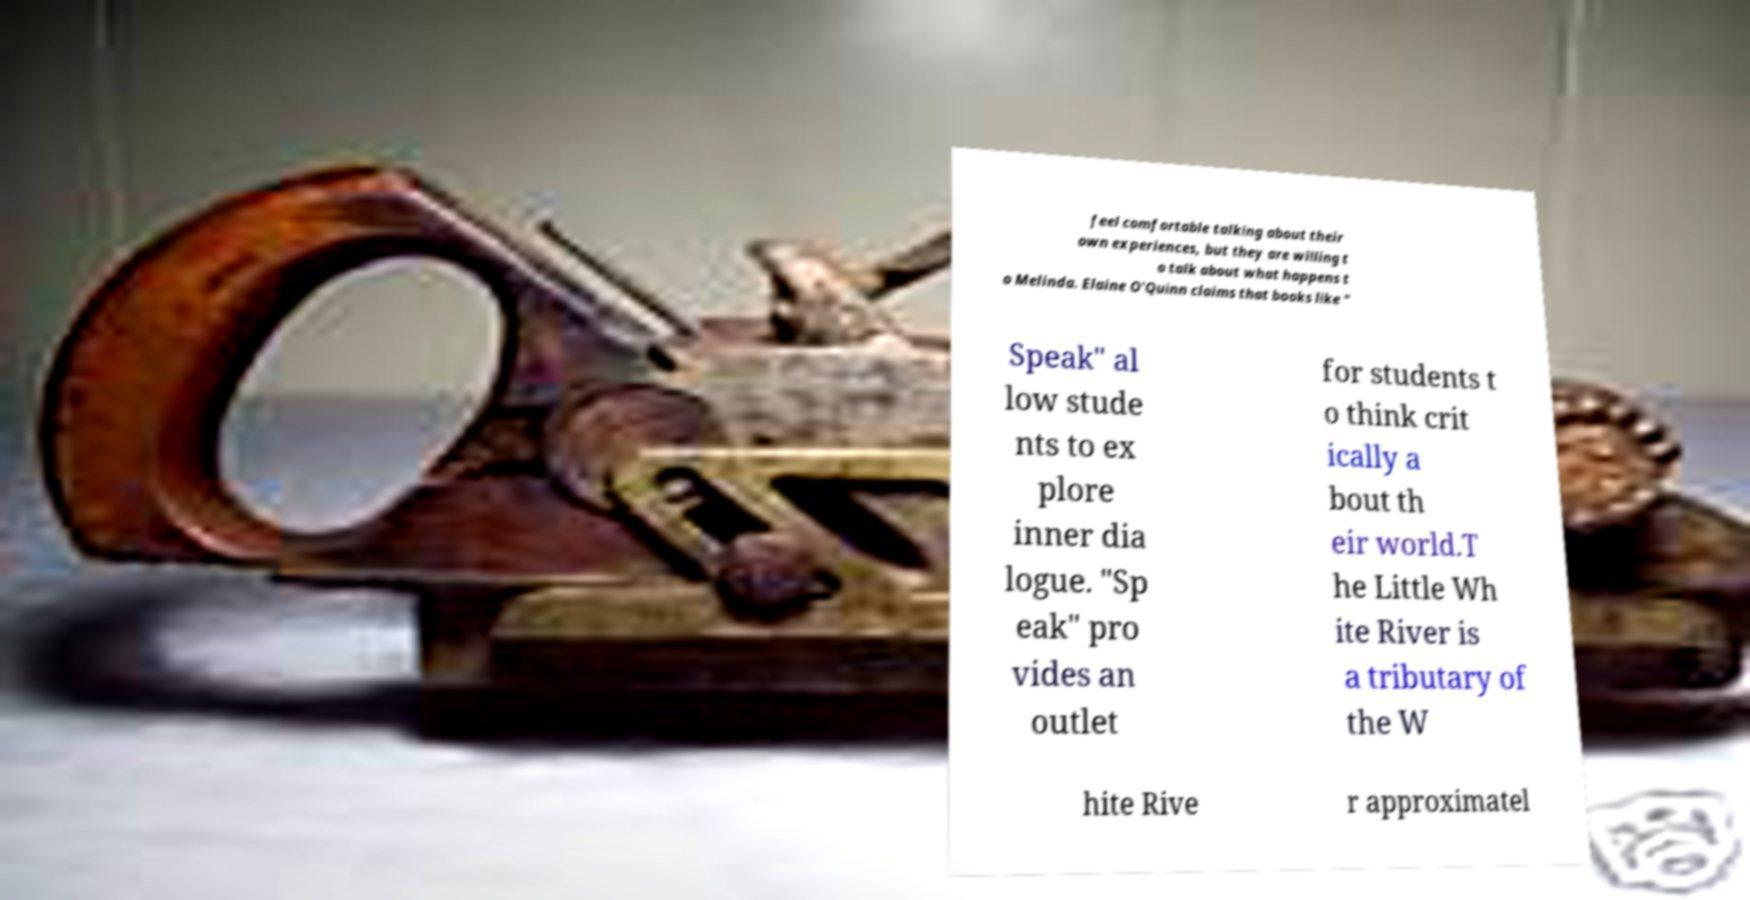Please identify and transcribe the text found in this image. feel comfortable talking about their own experiences, but they are willing t o talk about what happens t o Melinda. Elaine O'Quinn claims that books like " Speak" al low stude nts to ex plore inner dia logue. "Sp eak" pro vides an outlet for students t o think crit ically a bout th eir world.T he Little Wh ite River is a tributary of the W hite Rive r approximatel 